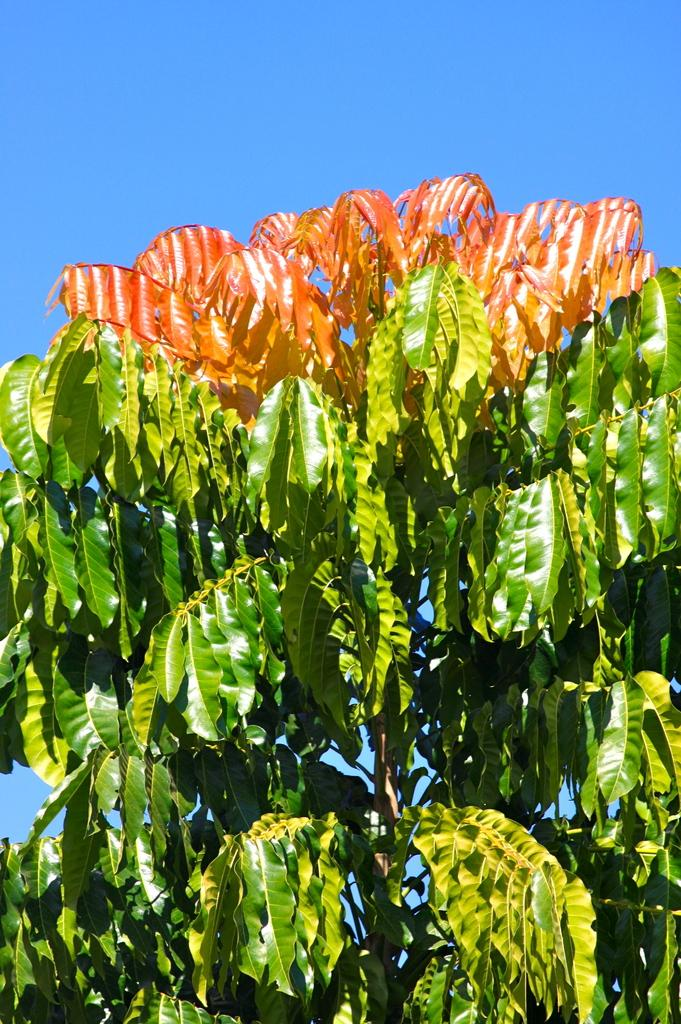What type of plant can be seen in the image? There is a tree in the image. What part of the natural environment is visible in the image? The sky is visible in the image. What type of guitar is the son playing in the image? There is no guitar or son present in the image; it only features a tree and the sky. 